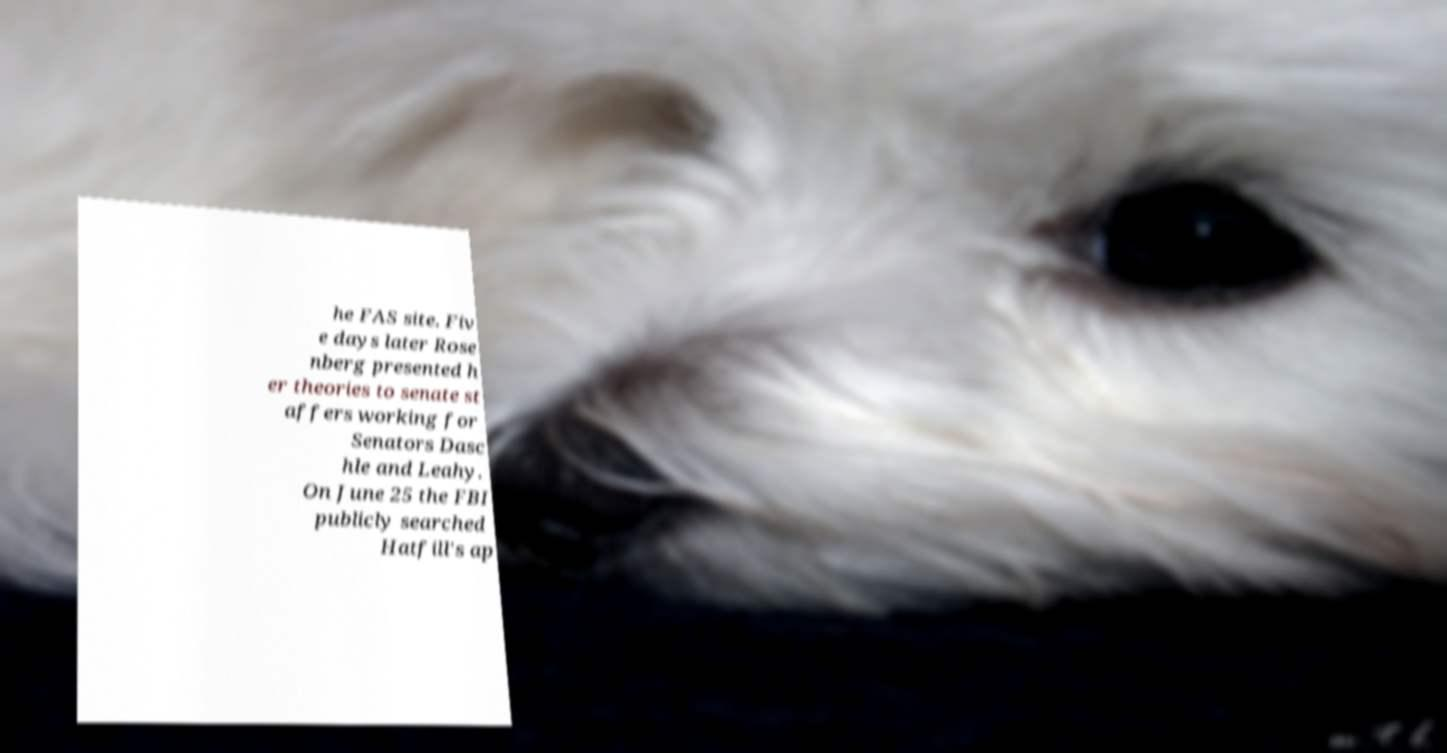For documentation purposes, I need the text within this image transcribed. Could you provide that? he FAS site. Fiv e days later Rose nberg presented h er theories to senate st affers working for Senators Dasc hle and Leahy. On June 25 the FBI publicly searched Hatfill's ap 